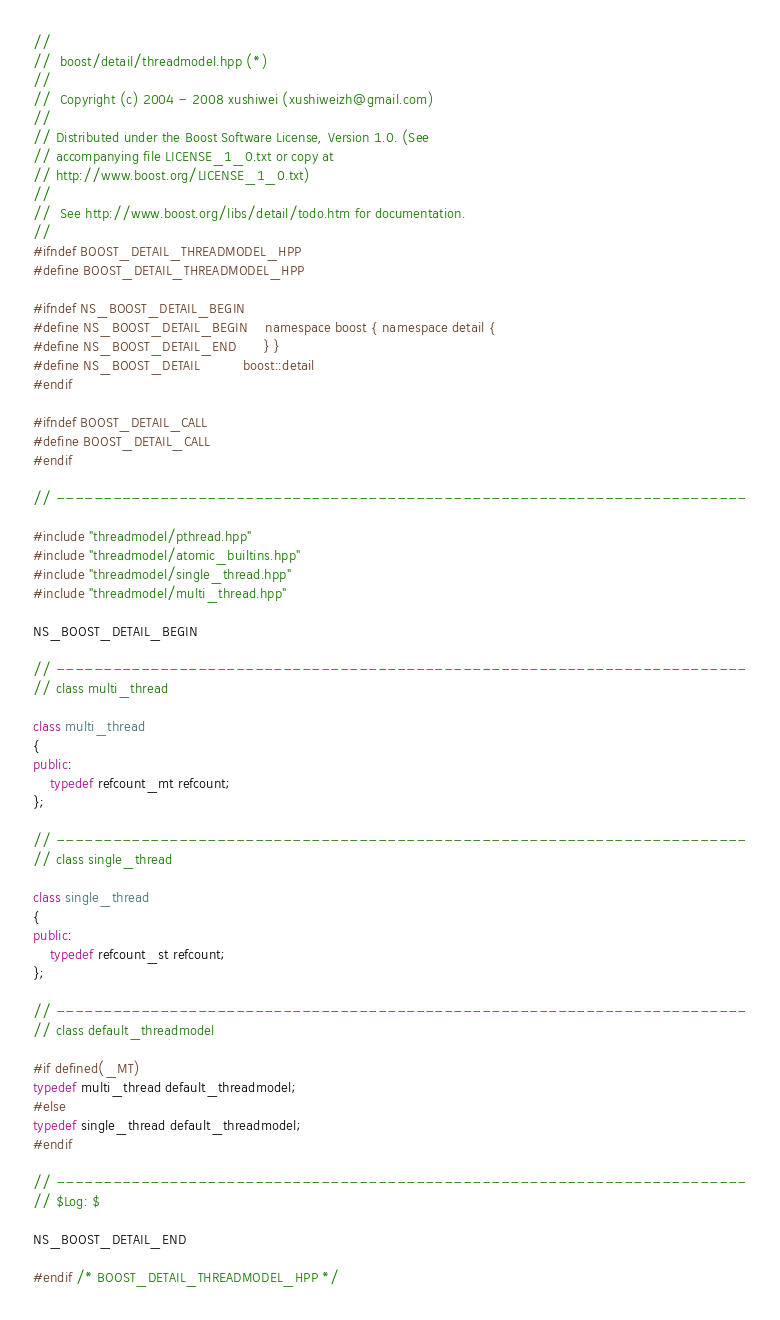Convert code to text. <code><loc_0><loc_0><loc_500><loc_500><_C++_>//
//  boost/detail/threadmodel.hpp (*)
//
//  Copyright (c) 2004 - 2008 xushiwei (xushiweizh@gmail.com)
//
// Distributed under the Boost Software License, Version 1.0. (See
// accompanying file LICENSE_1_0.txt or copy at
// http://www.boost.org/LICENSE_1_0.txt)
//
//  See http://www.boost.org/libs/detail/todo.htm for documentation.
//
#ifndef BOOST_DETAIL_THREADMODEL_HPP
#define BOOST_DETAIL_THREADMODEL_HPP

#ifndef NS_BOOST_DETAIL_BEGIN
#define NS_BOOST_DETAIL_BEGIN	namespace boost { namespace detail {
#define NS_BOOST_DETAIL_END		} }
#define NS_BOOST_DETAIL			boost::detail
#endif

#ifndef BOOST_DETAIL_CALL
#define BOOST_DETAIL_CALL
#endif

// -------------------------------------------------------------------------

#include "threadmodel/pthread.hpp"
#include "threadmodel/atomic_builtins.hpp"
#include "threadmodel/single_thread.hpp"
#include "threadmodel/multi_thread.hpp"

NS_BOOST_DETAIL_BEGIN

// -------------------------------------------------------------------------
// class multi_thread

class multi_thread
{
public:
    typedef refcount_mt refcount;
};

// -------------------------------------------------------------------------
// class single_thread

class single_thread
{
public:
    typedef refcount_st refcount;
};

// -------------------------------------------------------------------------
// class default_threadmodel

#if defined(_MT)
typedef multi_thread default_threadmodel;
#else
typedef single_thread default_threadmodel;
#endif

// -------------------------------------------------------------------------
// $Log: $

NS_BOOST_DETAIL_END

#endif /* BOOST_DETAIL_THREADMODEL_HPP */
</code> 